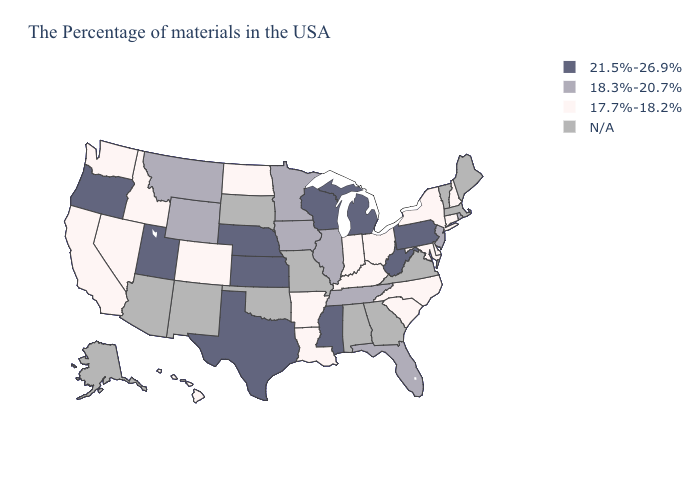Does Tennessee have the lowest value in the USA?
Concise answer only. No. What is the value of New York?
Be succinct. 17.7%-18.2%. What is the value of Arkansas?
Concise answer only. 17.7%-18.2%. Name the states that have a value in the range 18.3%-20.7%?
Quick response, please. Rhode Island, New Jersey, Florida, Tennessee, Illinois, Minnesota, Iowa, Wyoming, Montana. Name the states that have a value in the range 17.7%-18.2%?
Be succinct. New Hampshire, Connecticut, New York, Delaware, Maryland, North Carolina, South Carolina, Ohio, Kentucky, Indiana, Louisiana, Arkansas, North Dakota, Colorado, Idaho, Nevada, California, Washington, Hawaii. Which states have the lowest value in the USA?
Answer briefly. New Hampshire, Connecticut, New York, Delaware, Maryland, North Carolina, South Carolina, Ohio, Kentucky, Indiana, Louisiana, Arkansas, North Dakota, Colorado, Idaho, Nevada, California, Washington, Hawaii. Does Wyoming have the highest value in the USA?
Keep it brief. No. Name the states that have a value in the range 18.3%-20.7%?
Quick response, please. Rhode Island, New Jersey, Florida, Tennessee, Illinois, Minnesota, Iowa, Wyoming, Montana. Does the first symbol in the legend represent the smallest category?
Concise answer only. No. Name the states that have a value in the range N/A?
Write a very short answer. Maine, Massachusetts, Vermont, Virginia, Georgia, Alabama, Missouri, Oklahoma, South Dakota, New Mexico, Arizona, Alaska. What is the value of Indiana?
Keep it brief. 17.7%-18.2%. What is the value of South Dakota?
Be succinct. N/A. Is the legend a continuous bar?
Give a very brief answer. No. 